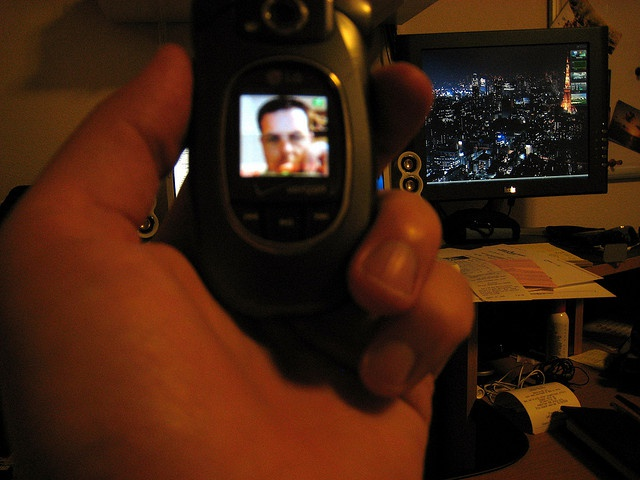Describe the objects in this image and their specific colors. I can see people in maroon, black, and brown tones, cell phone in maroon, black, white, and brown tones, tv in maroon, black, gray, navy, and darkgray tones, and people in maroon, white, brown, and lightpink tones in this image. 